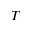Convert formula to latex. <formula><loc_0><loc_0><loc_500><loc_500>T</formula> 